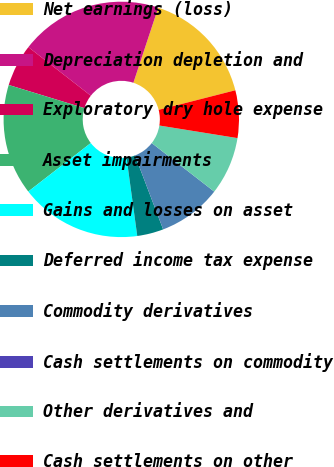Convert chart. <chart><loc_0><loc_0><loc_500><loc_500><pie_chart><fcel>Net earnings (loss)<fcel>Depreciation depletion and<fcel>Exploratory dry hole expense<fcel>Asset impairments<fcel>Gains and losses on asset<fcel>Deferred income tax expense<fcel>Commodity derivatives<fcel>Cash settlements on commodity<fcel>Other derivatives and<fcel>Cash settlements on other<nl><fcel>15.94%<fcel>19.56%<fcel>5.8%<fcel>15.22%<fcel>16.67%<fcel>3.62%<fcel>8.7%<fcel>0.0%<fcel>7.97%<fcel>6.52%<nl></chart> 